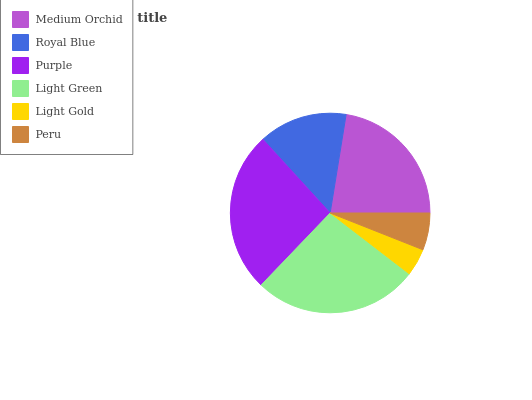Is Light Gold the minimum?
Answer yes or no. Yes. Is Light Green the maximum?
Answer yes or no. Yes. Is Royal Blue the minimum?
Answer yes or no. No. Is Royal Blue the maximum?
Answer yes or no. No. Is Medium Orchid greater than Royal Blue?
Answer yes or no. Yes. Is Royal Blue less than Medium Orchid?
Answer yes or no. Yes. Is Royal Blue greater than Medium Orchid?
Answer yes or no. No. Is Medium Orchid less than Royal Blue?
Answer yes or no. No. Is Medium Orchid the high median?
Answer yes or no. Yes. Is Royal Blue the low median?
Answer yes or no. Yes. Is Light Gold the high median?
Answer yes or no. No. Is Purple the low median?
Answer yes or no. No. 